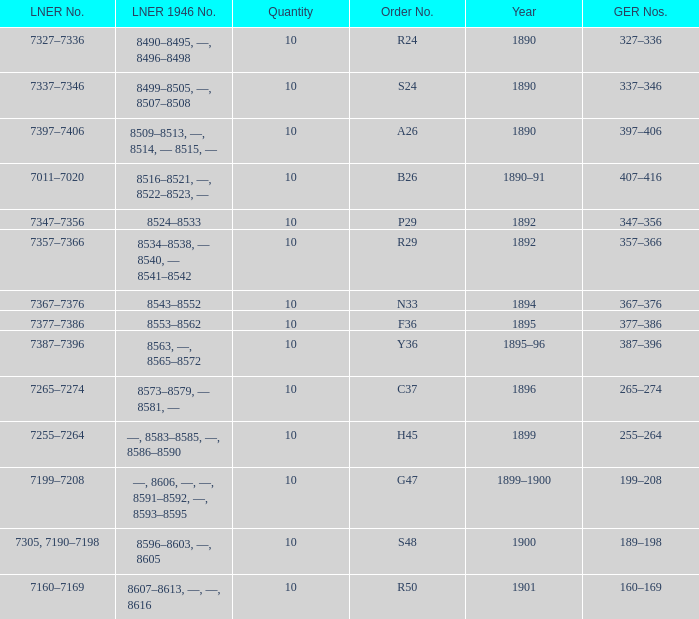What is order S24's LNER 1946 number? 8499–8505, —, 8507–8508. 